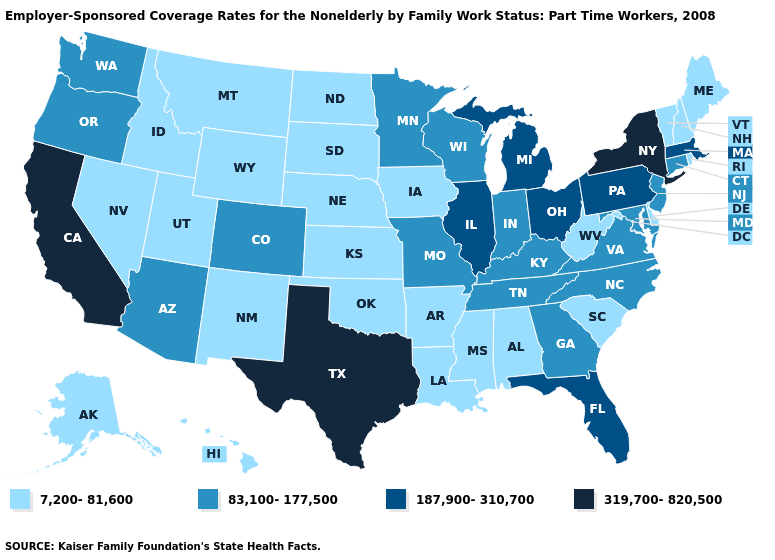Which states have the lowest value in the MidWest?
Be succinct. Iowa, Kansas, Nebraska, North Dakota, South Dakota. Name the states that have a value in the range 319,700-820,500?
Write a very short answer. California, New York, Texas. Name the states that have a value in the range 7,200-81,600?
Answer briefly. Alabama, Alaska, Arkansas, Delaware, Hawaii, Idaho, Iowa, Kansas, Louisiana, Maine, Mississippi, Montana, Nebraska, Nevada, New Hampshire, New Mexico, North Dakota, Oklahoma, Rhode Island, South Carolina, South Dakota, Utah, Vermont, West Virginia, Wyoming. Name the states that have a value in the range 7,200-81,600?
Give a very brief answer. Alabama, Alaska, Arkansas, Delaware, Hawaii, Idaho, Iowa, Kansas, Louisiana, Maine, Mississippi, Montana, Nebraska, Nevada, New Hampshire, New Mexico, North Dakota, Oklahoma, Rhode Island, South Carolina, South Dakota, Utah, Vermont, West Virginia, Wyoming. What is the lowest value in states that border New York?
Give a very brief answer. 7,200-81,600. Name the states that have a value in the range 7,200-81,600?
Be succinct. Alabama, Alaska, Arkansas, Delaware, Hawaii, Idaho, Iowa, Kansas, Louisiana, Maine, Mississippi, Montana, Nebraska, Nevada, New Hampshire, New Mexico, North Dakota, Oklahoma, Rhode Island, South Carolina, South Dakota, Utah, Vermont, West Virginia, Wyoming. Among the states that border Tennessee , which have the highest value?
Keep it brief. Georgia, Kentucky, Missouri, North Carolina, Virginia. What is the value of Connecticut?
Concise answer only. 83,100-177,500. Name the states that have a value in the range 187,900-310,700?
Quick response, please. Florida, Illinois, Massachusetts, Michigan, Ohio, Pennsylvania. Does Arizona have the lowest value in the West?
Keep it brief. No. Which states have the lowest value in the MidWest?
Answer briefly. Iowa, Kansas, Nebraska, North Dakota, South Dakota. What is the value of Wyoming?
Keep it brief. 7,200-81,600. What is the highest value in the USA?
Concise answer only. 319,700-820,500. Does the first symbol in the legend represent the smallest category?
Quick response, please. Yes. What is the lowest value in states that border Massachusetts?
Keep it brief. 7,200-81,600. 